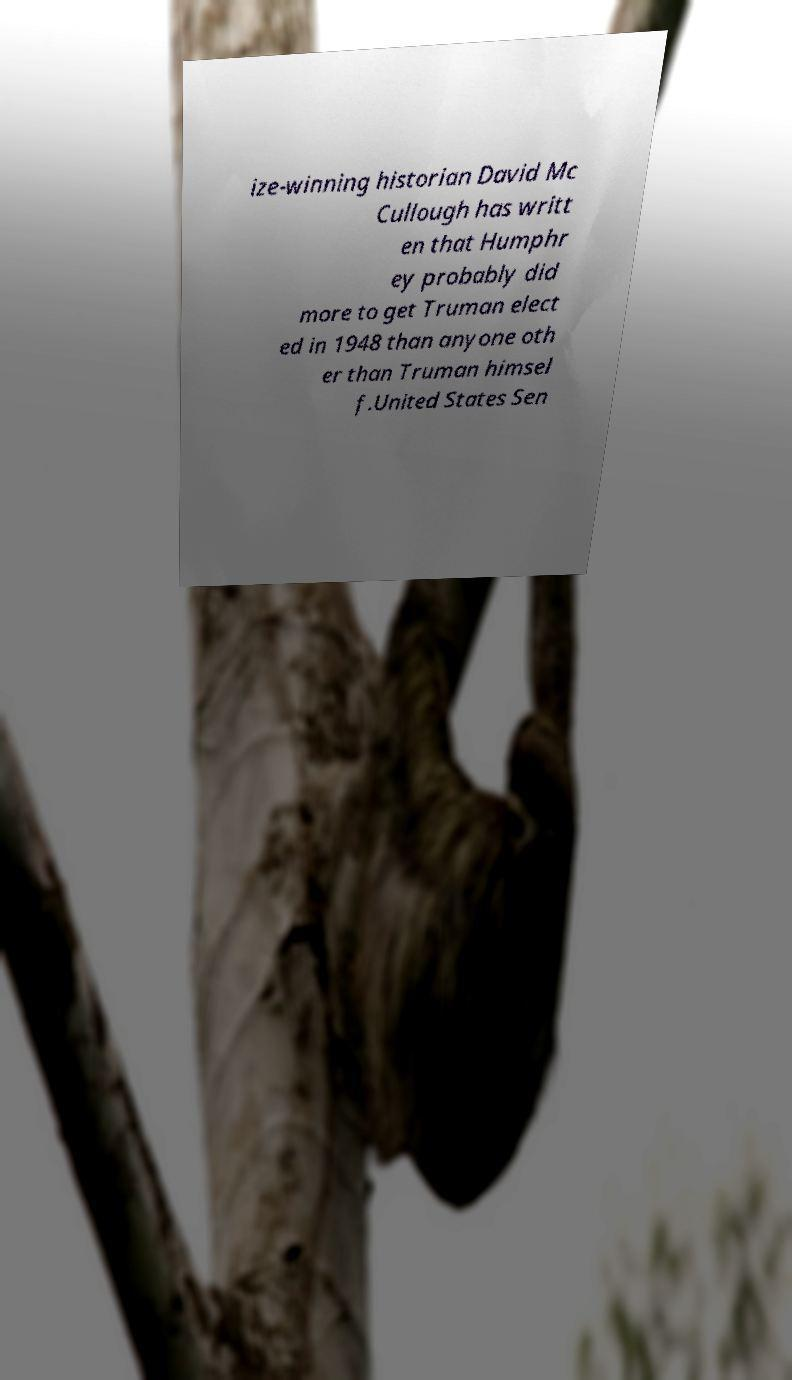I need the written content from this picture converted into text. Can you do that? ize-winning historian David Mc Cullough has writt en that Humphr ey probably did more to get Truman elect ed in 1948 than anyone oth er than Truman himsel f.United States Sen 